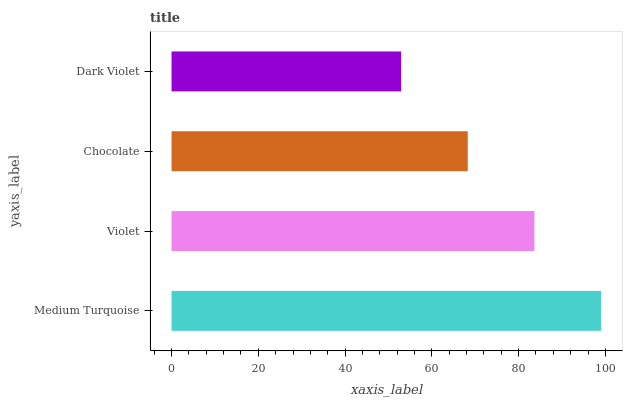Is Dark Violet the minimum?
Answer yes or no. Yes. Is Medium Turquoise the maximum?
Answer yes or no. Yes. Is Violet the minimum?
Answer yes or no. No. Is Violet the maximum?
Answer yes or no. No. Is Medium Turquoise greater than Violet?
Answer yes or no. Yes. Is Violet less than Medium Turquoise?
Answer yes or no. Yes. Is Violet greater than Medium Turquoise?
Answer yes or no. No. Is Medium Turquoise less than Violet?
Answer yes or no. No. Is Violet the high median?
Answer yes or no. Yes. Is Chocolate the low median?
Answer yes or no. Yes. Is Medium Turquoise the high median?
Answer yes or no. No. Is Dark Violet the low median?
Answer yes or no. No. 